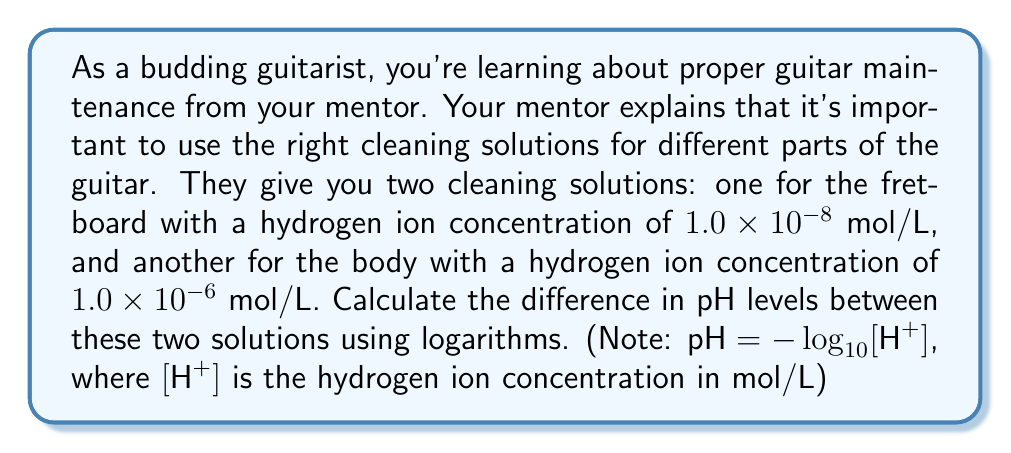Can you answer this question? Let's approach this step-by-step:

1) We're given the formula for pH: $\text{pH} = -\log_{10}[\text{H}^+]$

2) For the fretboard cleaning solution:
   $[\text{H}^+] = 1.0 \times 10^{-8}$ mol/L
   $\text{pH}_{\text{fretboard}} = -\log_{10}(1.0 \times 10^{-8})$
   $= -(-8) = 8$

3) For the body cleaning solution:
   $[\text{H}^+] = 1.0 \times 10^{-6}$ mol/L
   $\text{pH}_{\text{body}} = -\log_{10}(1.0 \times 10^{-6})$
   $= -(-6) = 6$

4) To find the difference in pH levels:
   $\text{pH difference} = \text{pH}_{\text{fretboard}} - \text{pH}_{\text{body}}$
   $= 8 - 6 = 2$

Therefore, the difference in pH levels between the two cleaning solutions is 2.
Answer: The difference in pH levels between the fretboard cleaning solution and the body cleaning solution is 2. 